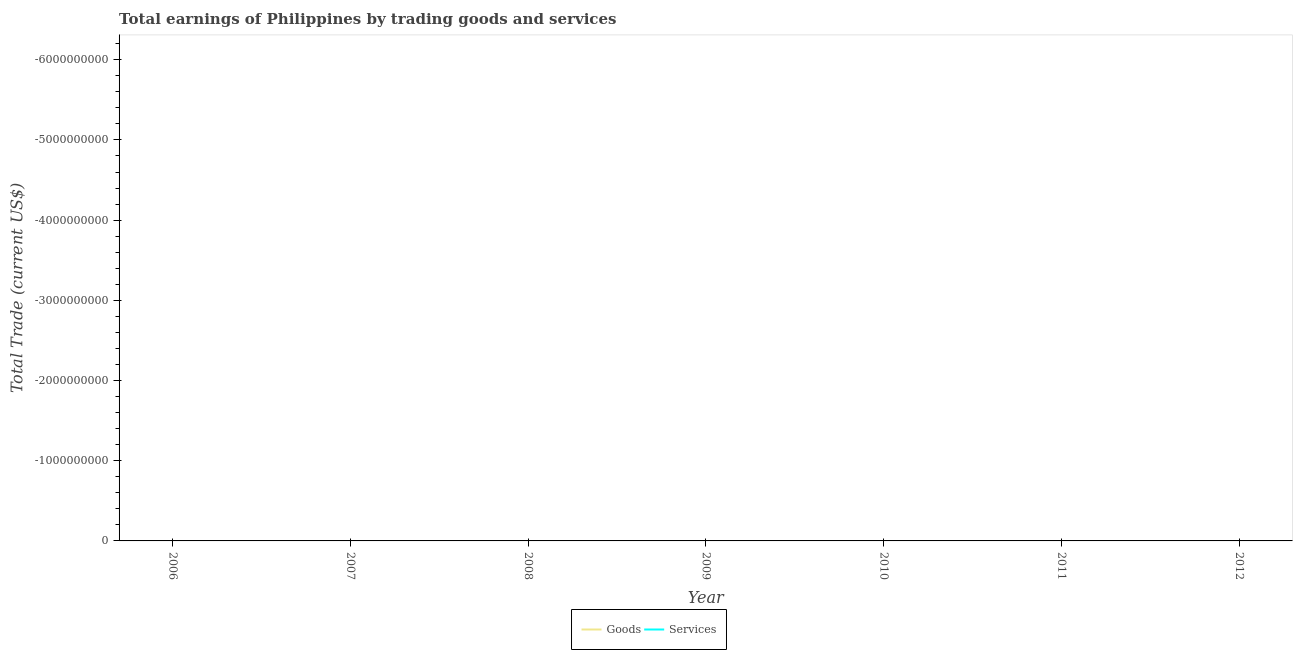Is the number of lines equal to the number of legend labels?
Ensure brevity in your answer.  No. Across all years, what is the minimum amount earned by trading goods?
Your response must be concise. 0. What is the difference between the amount earned by trading goods in 2008 and the amount earned by trading services in 2012?
Offer a terse response. 0. In how many years, is the amount earned by trading services greater than the average amount earned by trading services taken over all years?
Offer a terse response. 0. Is the amount earned by trading goods strictly less than the amount earned by trading services over the years?
Keep it short and to the point. Yes. How many years are there in the graph?
Offer a terse response. 7. What is the difference between two consecutive major ticks on the Y-axis?
Keep it short and to the point. 1.00e+09. Are the values on the major ticks of Y-axis written in scientific E-notation?
Provide a succinct answer. No. How are the legend labels stacked?
Ensure brevity in your answer.  Horizontal. What is the title of the graph?
Keep it short and to the point. Total earnings of Philippines by trading goods and services. Does "Male labor force" appear as one of the legend labels in the graph?
Keep it short and to the point. No. What is the label or title of the Y-axis?
Offer a very short reply. Total Trade (current US$). What is the Total Trade (current US$) of Goods in 2006?
Provide a succinct answer. 0. What is the Total Trade (current US$) of Goods in 2007?
Your answer should be very brief. 0. What is the Total Trade (current US$) in Goods in 2008?
Your response must be concise. 0. What is the Total Trade (current US$) of Goods in 2012?
Provide a succinct answer. 0. What is the total Total Trade (current US$) in Goods in the graph?
Your answer should be very brief. 0. 